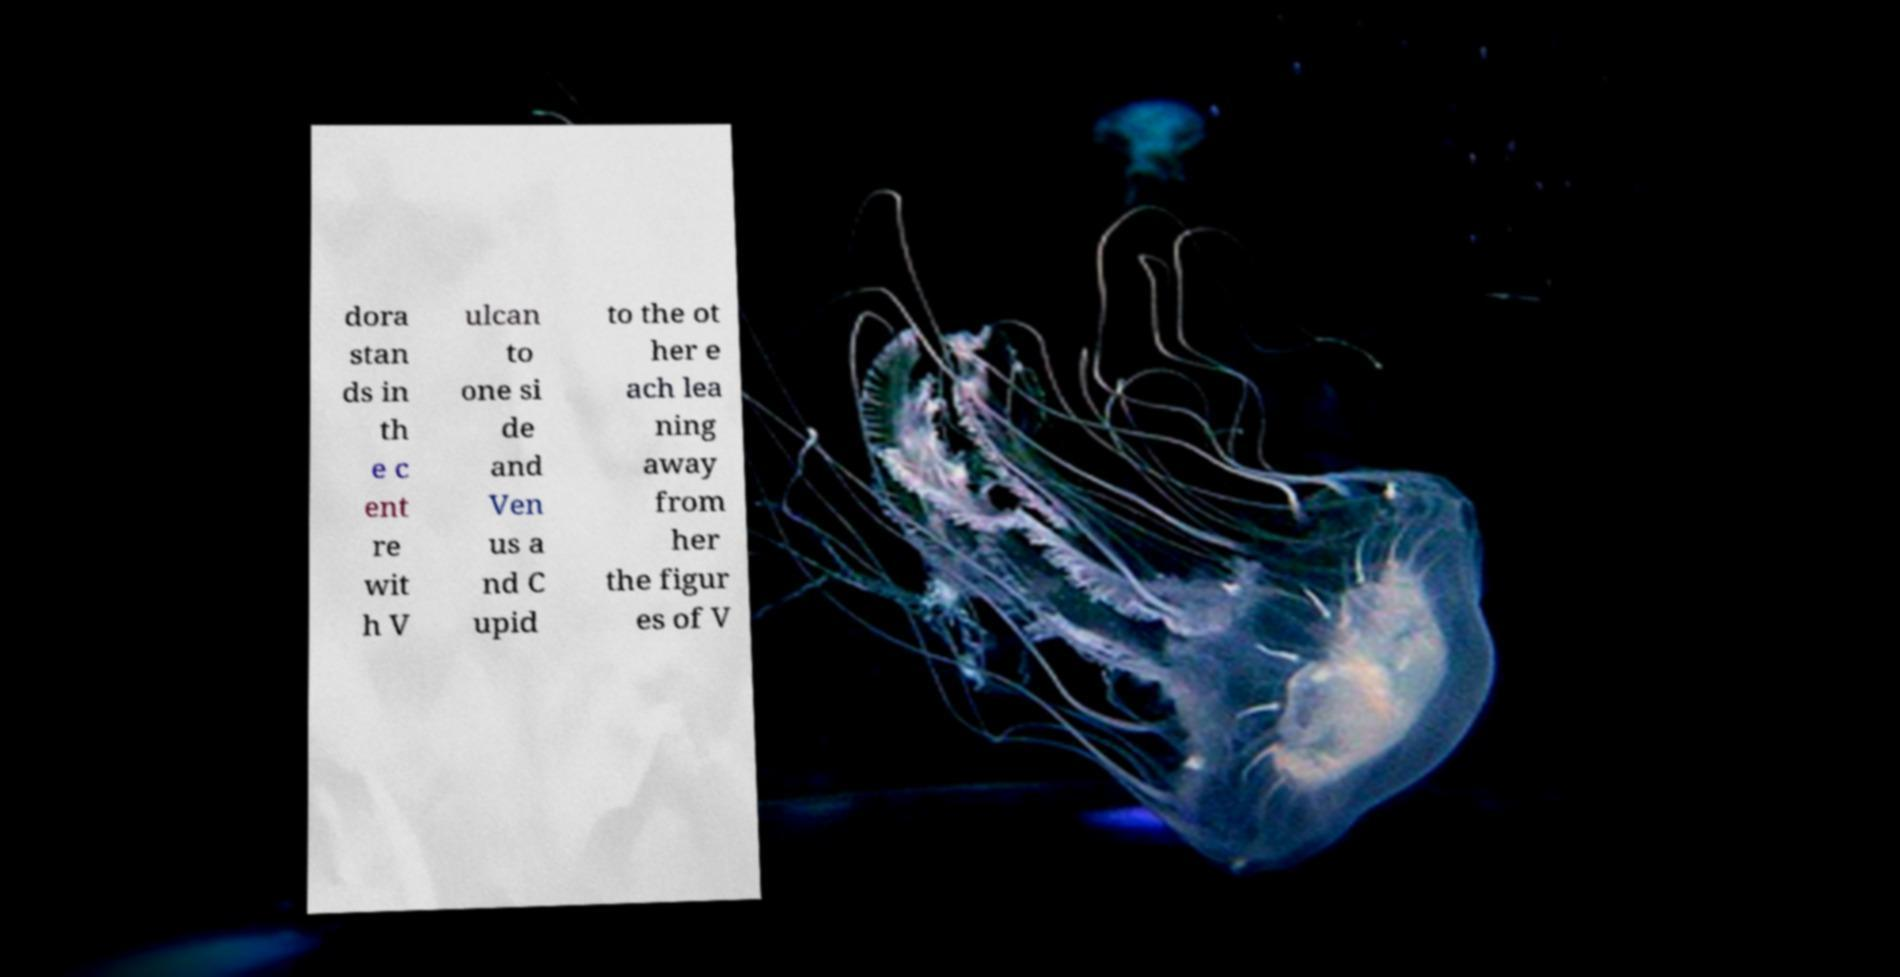Could you extract and type out the text from this image? dora stan ds in th e c ent re wit h V ulcan to one si de and Ven us a nd C upid to the ot her e ach lea ning away from her the figur es of V 